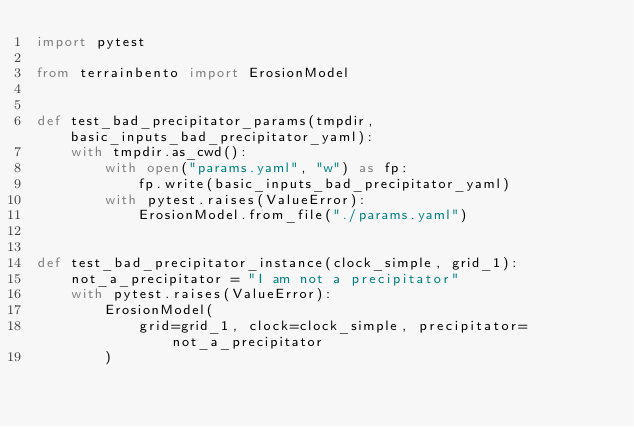Convert code to text. <code><loc_0><loc_0><loc_500><loc_500><_Python_>import pytest

from terrainbento import ErosionModel


def test_bad_precipitator_params(tmpdir, basic_inputs_bad_precipitator_yaml):
    with tmpdir.as_cwd():
        with open("params.yaml", "w") as fp:
            fp.write(basic_inputs_bad_precipitator_yaml)
        with pytest.raises(ValueError):
            ErosionModel.from_file("./params.yaml")


def test_bad_precipitator_instance(clock_simple, grid_1):
    not_a_precipitator = "I am not a precipitator"
    with pytest.raises(ValueError):
        ErosionModel(
            grid=grid_1, clock=clock_simple, precipitator=not_a_precipitator
        )
</code> 